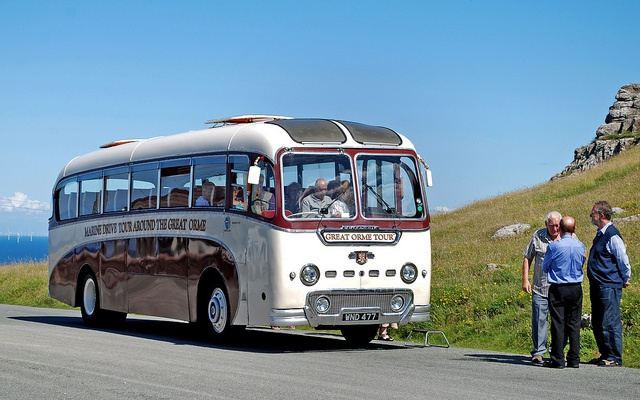Describe the objects in this image and their specific colors. I can see bus in lightblue, gray, black, white, and darkgray tones, people in lightblue, black, navy, darkblue, and gray tones, people in lightblue, black, darkgray, navy, and gray tones, people in lightblue, gray, black, darkgray, and navy tones, and people in lightblue, darkgray, gray, lightgray, and black tones in this image. 